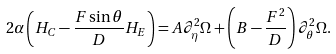<formula> <loc_0><loc_0><loc_500><loc_500>2 \alpha \left ( H _ { C } - \frac { F \sin \theta } { D } H _ { E } \right ) = A \partial _ { \eta } ^ { 2 } \Omega + \left ( B - \frac { F ^ { 2 } } { D } \right ) \partial _ { \theta } ^ { 2 } \Omega .</formula> 